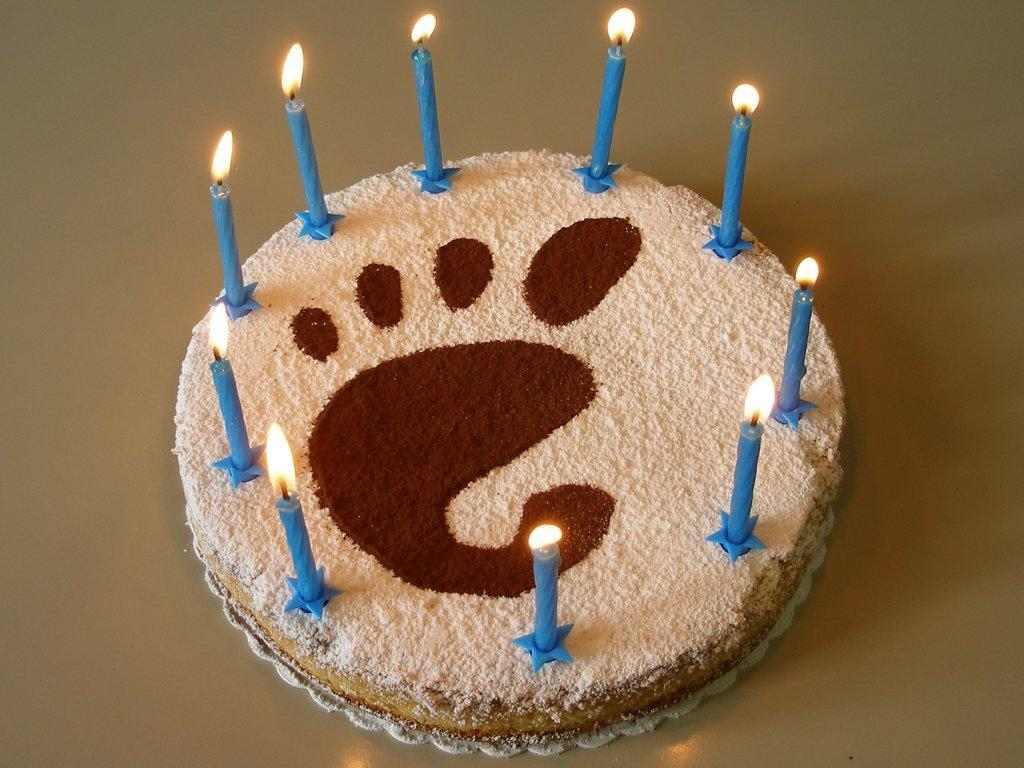What is the main subject of the image? There is a cake in the image. How is the cake positioned in the image? The cake is placed on a platform. What is present on top of the cake? There is a group of candles on the cake. What type of cat can be seen eating breakfast on the cake in the image? There is no cat or breakfast present on the cake in the image; it only features a group of candles. 